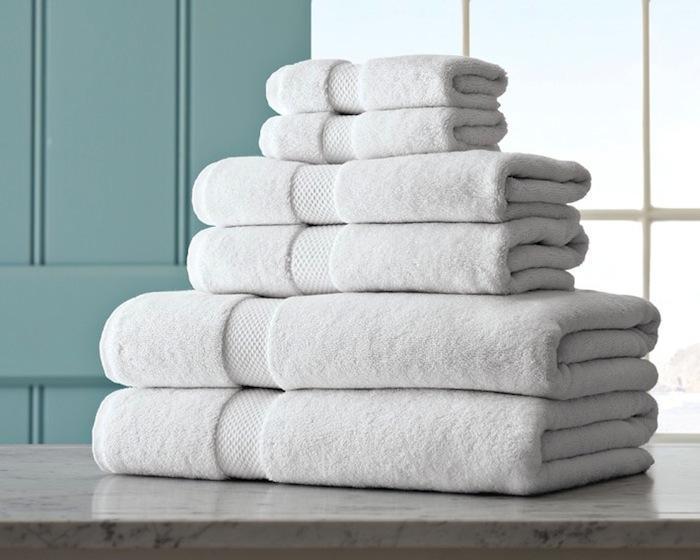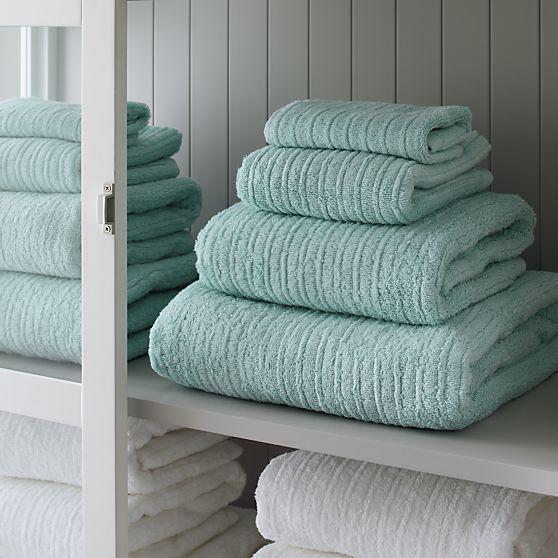The first image is the image on the left, the second image is the image on the right. For the images displayed, is the sentence "The towels in the image on the left are gray." factually correct? Answer yes or no. No. The first image is the image on the left, the second image is the image on the right. Examine the images to the left and right. Is the description "The leftmost images feature a stack of grey towels." accurate? Answer yes or no. No. 